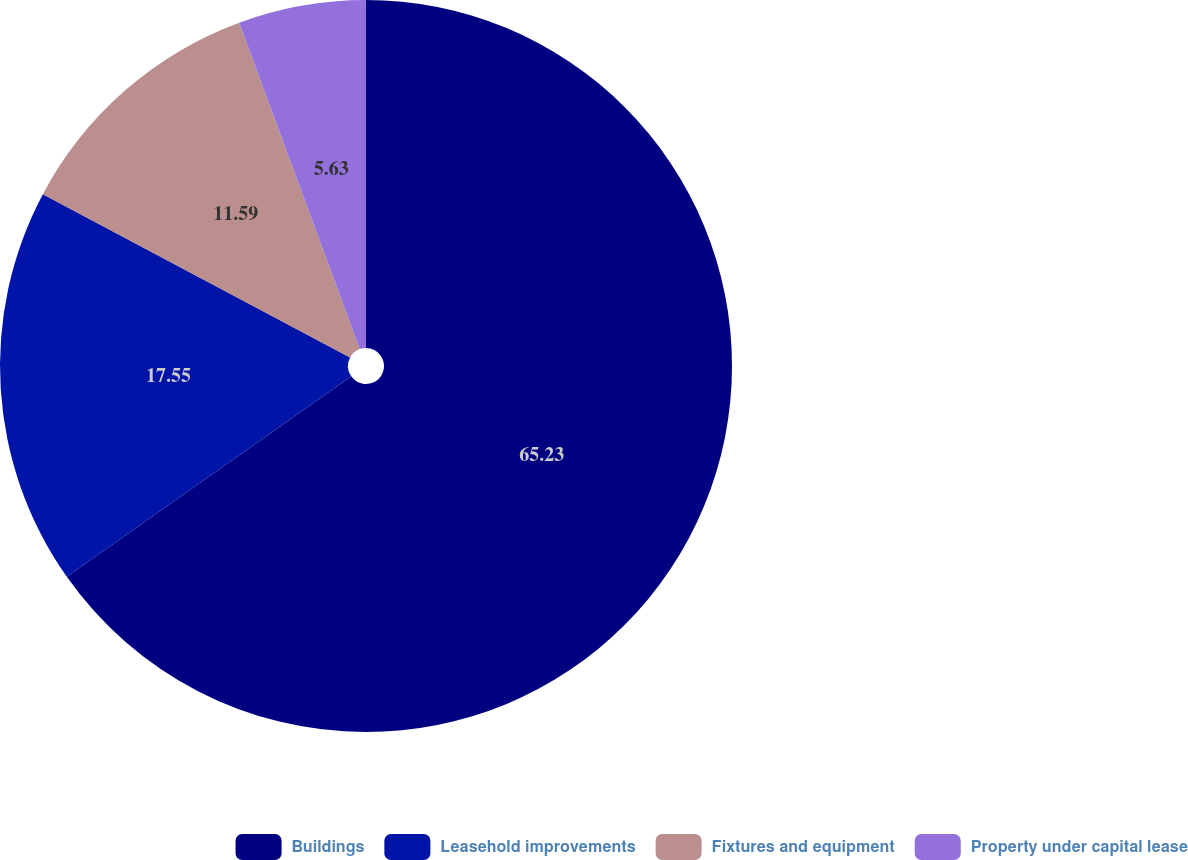Convert chart to OTSL. <chart><loc_0><loc_0><loc_500><loc_500><pie_chart><fcel>Buildings<fcel>Leasehold improvements<fcel>Fixtures and equipment<fcel>Property under capital lease<nl><fcel>65.23%<fcel>17.55%<fcel>11.59%<fcel>5.63%<nl></chart> 